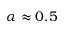<formula> <loc_0><loc_0><loc_500><loc_500>\alpha \approx 0 . 5</formula> 